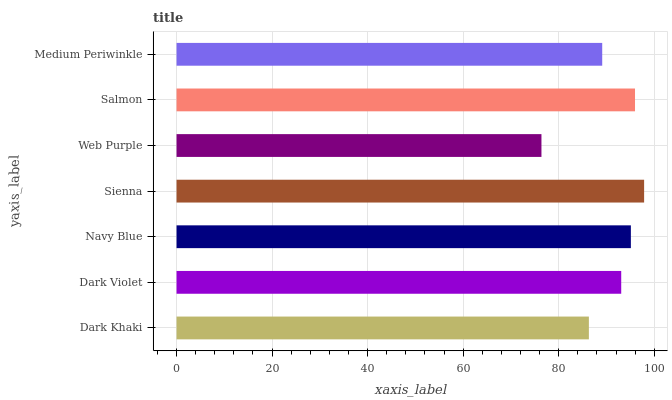Is Web Purple the minimum?
Answer yes or no. Yes. Is Sienna the maximum?
Answer yes or no. Yes. Is Dark Violet the minimum?
Answer yes or no. No. Is Dark Violet the maximum?
Answer yes or no. No. Is Dark Violet greater than Dark Khaki?
Answer yes or no. Yes. Is Dark Khaki less than Dark Violet?
Answer yes or no. Yes. Is Dark Khaki greater than Dark Violet?
Answer yes or no. No. Is Dark Violet less than Dark Khaki?
Answer yes or no. No. Is Dark Violet the high median?
Answer yes or no. Yes. Is Dark Violet the low median?
Answer yes or no. Yes. Is Sienna the high median?
Answer yes or no. No. Is Navy Blue the low median?
Answer yes or no. No. 